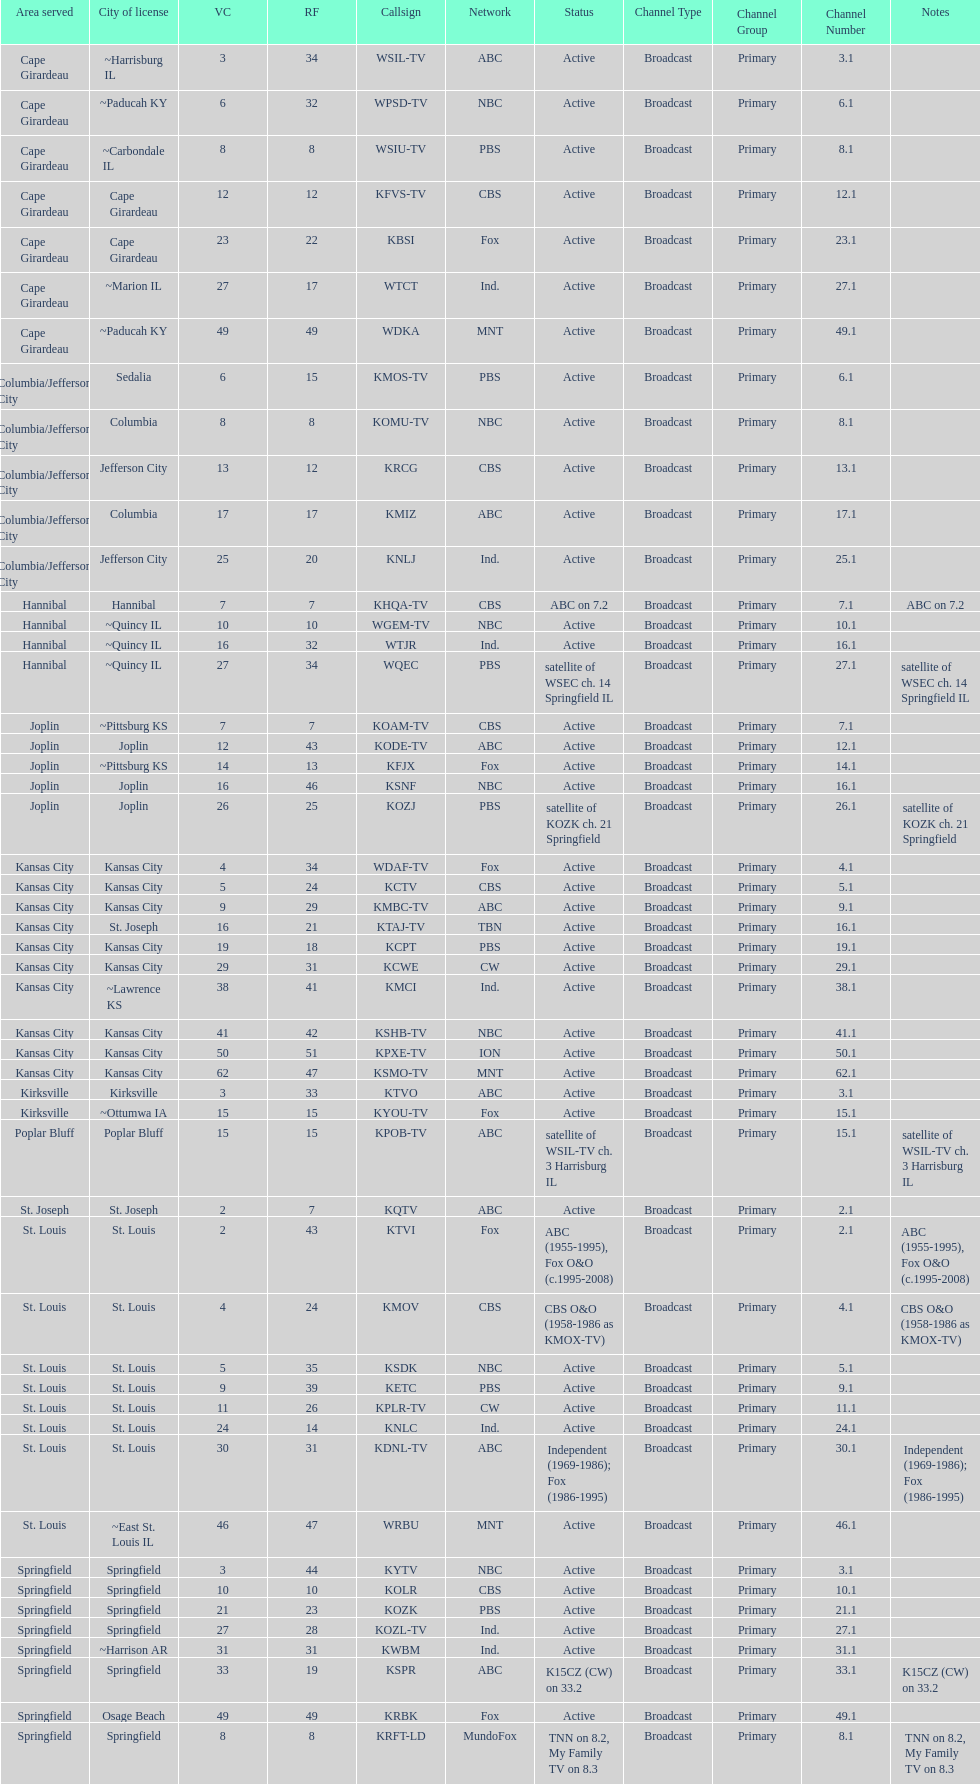How many of these missouri tv stations are actually licensed in a city in illinois (il)? 7. 